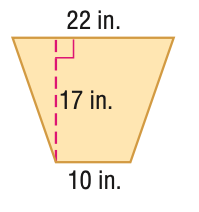Answer the mathemtical geometry problem and directly provide the correct option letter.
Question: Find the area of the trapezoid.
Choices: A: 68 B: 136 C: 272 D: 544 C 